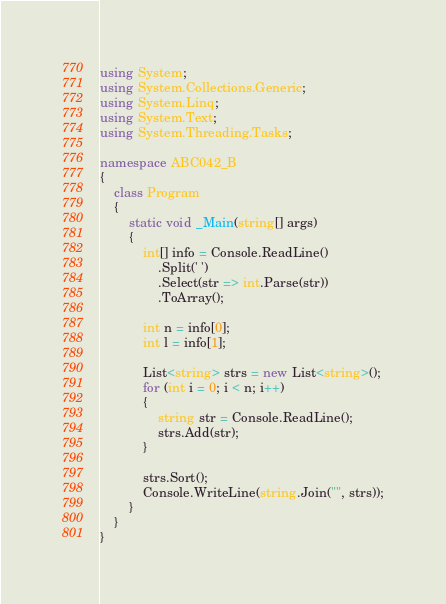<code> <loc_0><loc_0><loc_500><loc_500><_C#_>using System;
using System.Collections.Generic;
using System.Linq;
using System.Text;
using System.Threading.Tasks;

namespace ABC042_B
{
    class Program
    {
        static void _Main(string[] args)
        {
            int[] info = Console.ReadLine()
                .Split(' ')
                .Select(str => int.Parse(str))
                .ToArray();

            int n = info[0];
            int l = info[1];

            List<string> strs = new List<string>();
            for (int i = 0; i < n; i++)
            {
                string str = Console.ReadLine();
                strs.Add(str);
            }

            strs.Sort();
            Console.WriteLine(string.Join("", strs));
        }
    }
}</code> 